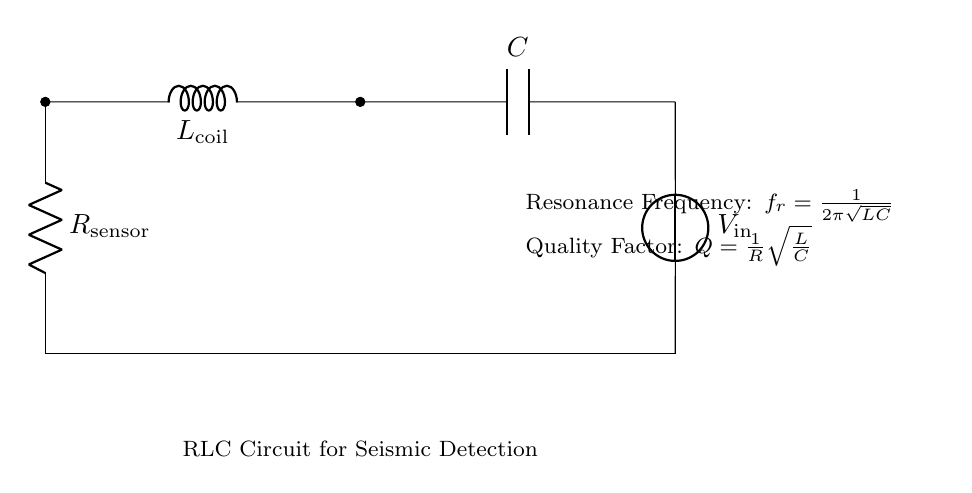What components make up the circuit? The circuit consists of a resistor, inductor, and capacitor. These are the basic passive components that form an RLC circuit.
Answer: Resistor, inductor, capacitor What is the role of the voltage source? The voltage source provides the necessary electrical energy to the circuit, allowing it to function and respond to the resonance conditions established by the RLC configuration.
Answer: Supply voltage What is the value of the resonance frequency formula? The resonance frequency is given by the formula f_r = 1/(2π√(LC)), where L is the inductance and C is the capacitance. This formula shows how the frequency depends on these two components.
Answer: f_r = 1/(2π√(LC)) How does the quality factor relate to resistance? The quality factor Q is inversely proportional to resistance in the formula Q = 1/R√(L/C). A lower resistance results in a higher quality factor, indicating a sharper resonance peak.
Answer: Inversely proportional Why is resonance important in seismic detection? Resonance allows the circuit to amplify specific frequencies, which can enhance the detection of seismic signals, making it easier to identify relevant data in seismic monitoring applications.
Answer: Amplifies seismic signals What is the effect of increasing the inductance on resonance frequency? Increasing the inductance L will decrease the resonance frequency f_r, since they are inversely related in the formula. This relationship indicates that a higher inductance leads to lower frequencies being amplified.
Answer: Decreases resonance frequency How does the configuration of an RLC circuit affect its quality factor? The quality factor is affected by the resistance, inductance, and capacitance values through the formula Q = 1/R√(L/C). Changing these values impacts how sharply the circuit resonates, thus affecting the quality factor.
Answer: Affects sharply resonance 